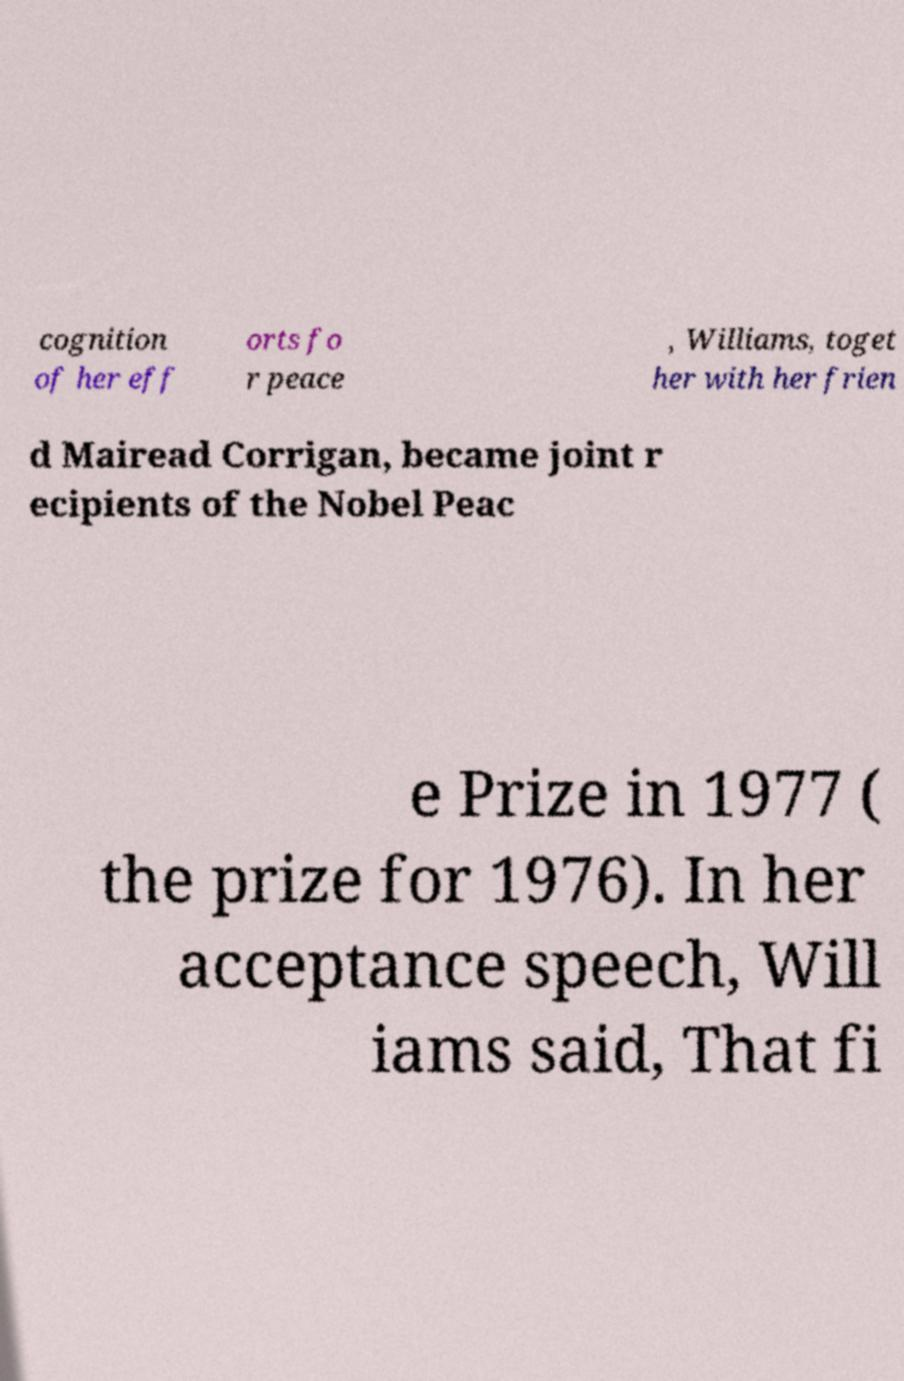Could you extract and type out the text from this image? cognition of her eff orts fo r peace , Williams, toget her with her frien d Mairead Corrigan, became joint r ecipients of the Nobel Peac e Prize in 1977 ( the prize for 1976). In her acceptance speech, Will iams said, That fi 